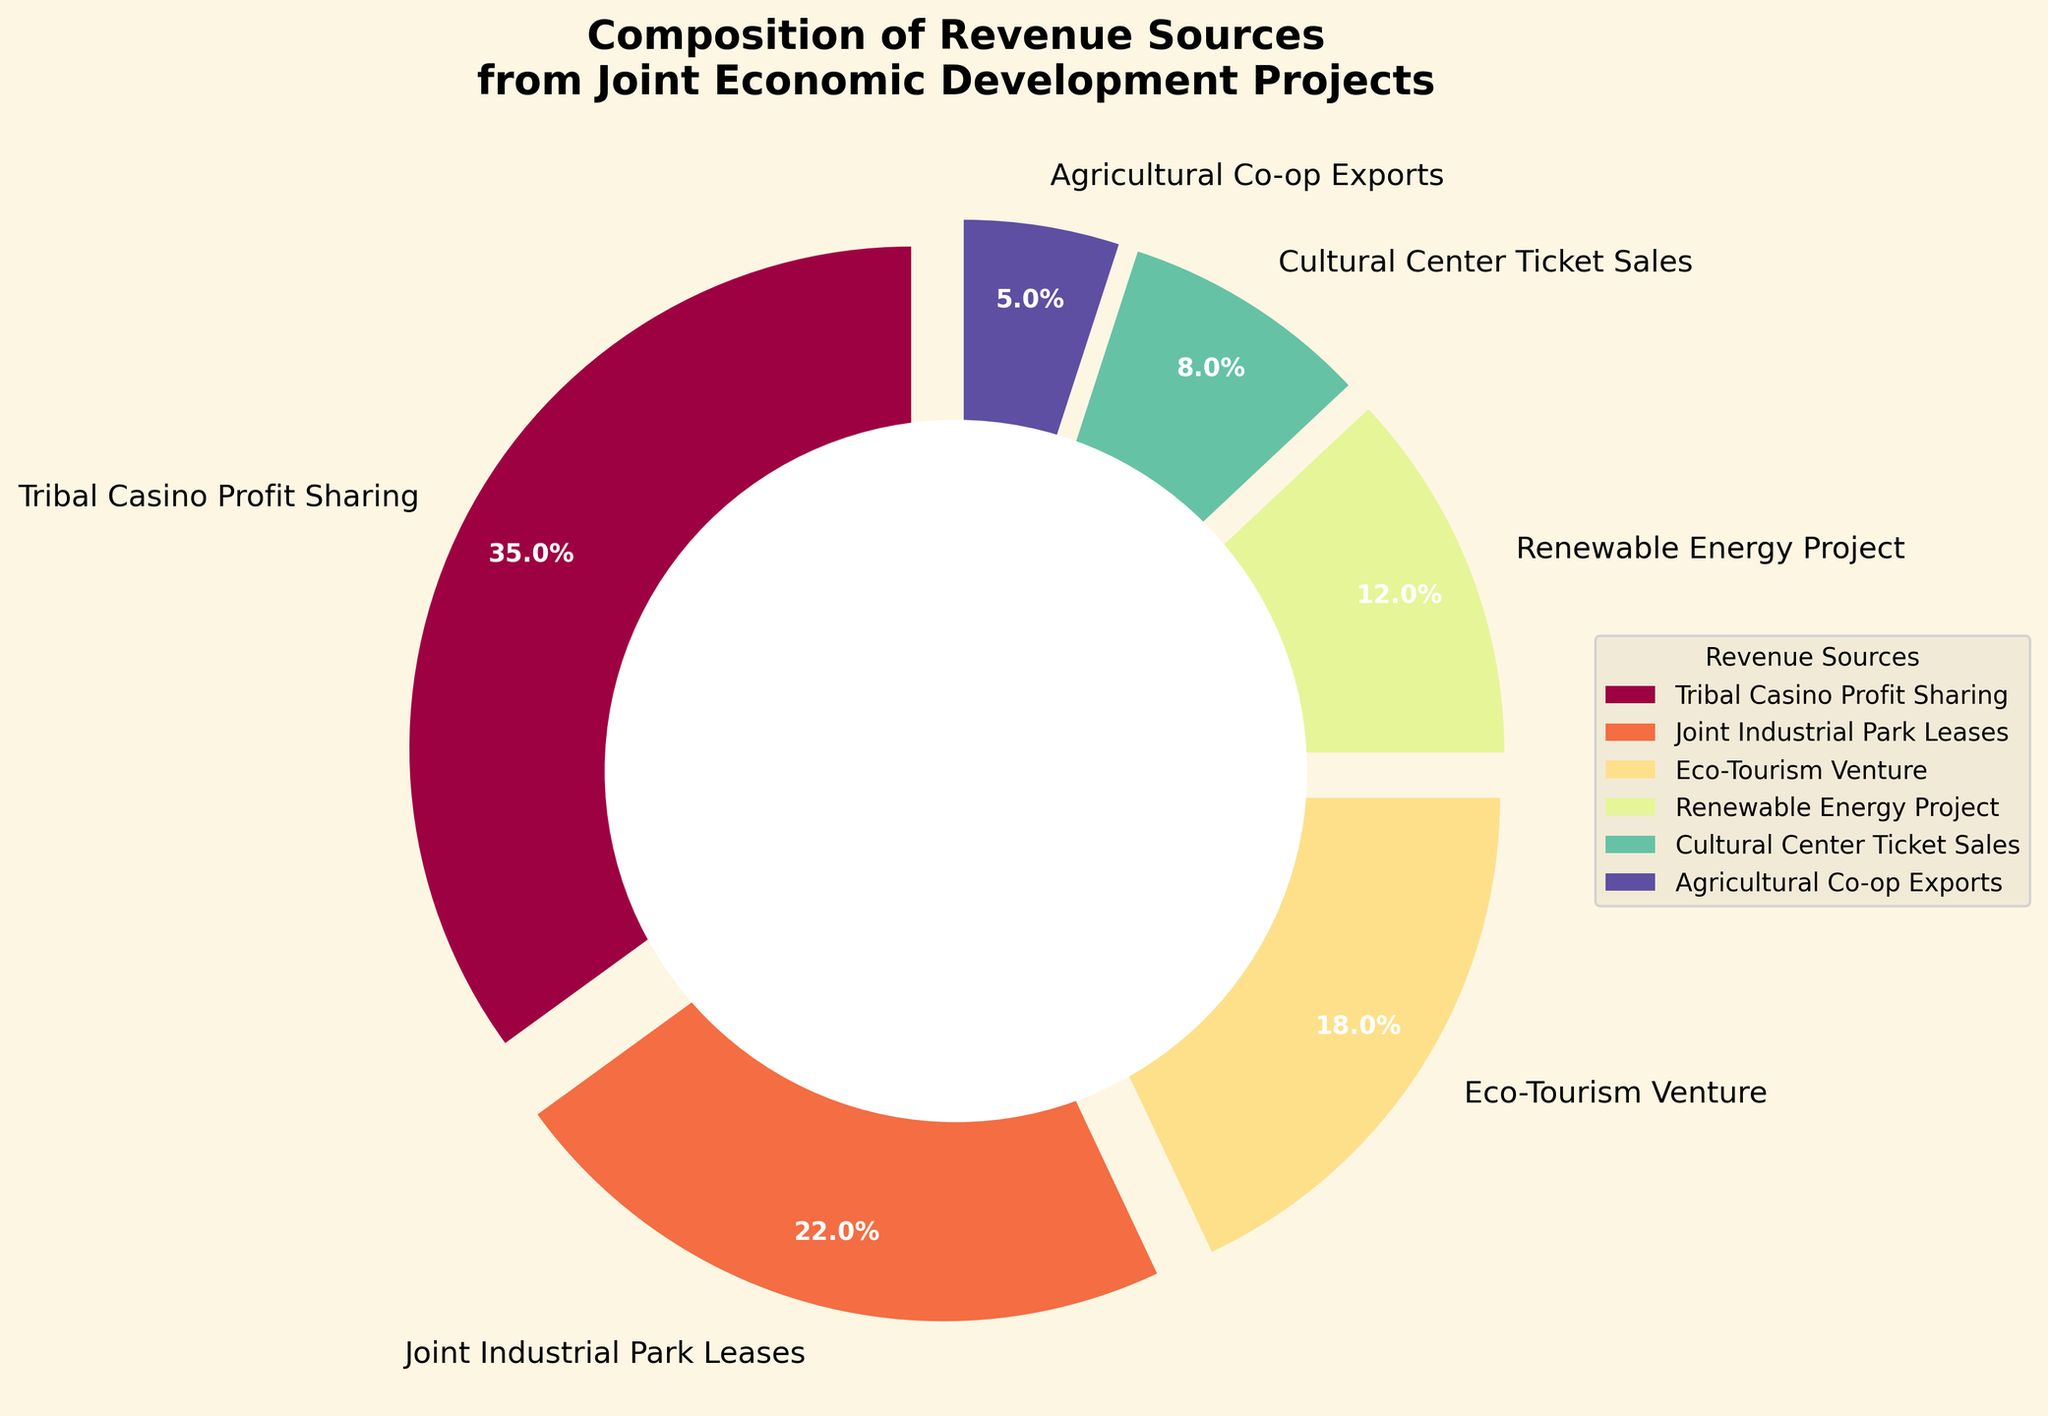What is the largest revenue source? The biggest section of the pie chart represents the largest revenue source. From the chart, the "Tribal Casino Profit Sharing" has the largest slice.
Answer: Tribal Casino Profit Sharing Which two revenue sources combined give the highest percentage? We need to find two slices that together make up the highest percentage. "Tribal Casino Profit Sharing" (35%) and "Joint Industrial Park Leases" (22%) combined give a sum of 57%, which is higher than any other combination.
Answer: Tribal Casino Profit Sharing and Joint Industrial Park Leases By what percentage does the Tribal Casino Profit Sharing exceed the Renewable Energy Project? Subtract the percentage of the "Renewable Energy Project" (12%) from the percentage of "Tribal Casino Profit Sharing" (35%). This results in 35% - 12% = 23%.
Answer: 23% Which revenue source has the smallest contribution and what is it? The smallest slice of the pie chart provides the answer. Here, the "Agricultural Co-op Exports" slice is the smallest.
Answer: Agricultural Co-op Exports with 5% How much greater is the percentage of Joint Industrial Park Leases compared to Cultural Center Ticket Sales? Subtract the percentage of the "Cultural Center Ticket Sales" (8%) from the percentage of "Joint Industrial Park Leases" (22%). This results in 22% - 8% = 14%.
Answer: 14% What is the combined contribution of the Eco-Tourism Venture and Renewable Energy Project? Sum the percentages of "Eco-Tourism Venture" (18%) and "Renewable Energy Project" (12%). This results in 18% + 12% = 30%.
Answer: 30% What color represents the Agricultural Co-op Exports? The color of the slice representing the "Agricultural Co-op Exports" in the pie chart should be observed directly.
Answer: Lightest color in the pie chart Which revenue source color is third in the legend from top to bottom? The legend lists the categories in the same order as their slices in the pie chart, moving clockwise from the top. The third in order is "Eco-Tourism Venture."
Answer: Orange Considering the "Cultural Center Ticket Sales" and "Agricultural Co-op Exports" together, do they contribute more or less than the Renewable Energy Project? Sum up "Cultural Center Ticket Sales" (8%) and "Agricultural Co-op Exports" (5%). The combined percentage is 8% + 5% = 13%, which is higher than "Renewable Energy Project" (12%).
Answer: More 